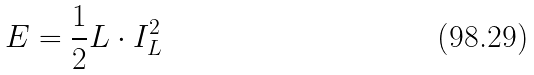<formula> <loc_0><loc_0><loc_500><loc_500>E = \frac { 1 } { 2 } L \cdot I _ { L } ^ { 2 }</formula> 